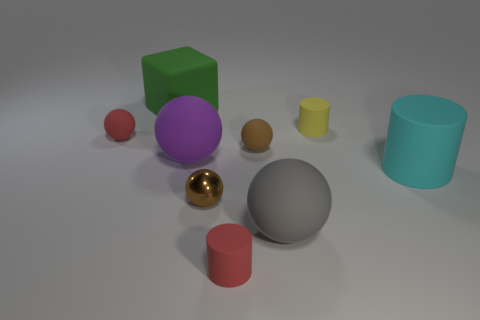There is a ball that is in front of the brown thing on the left side of the small matte sphere on the right side of the large cube; what size is it?
Your answer should be very brief. Large. There is a red rubber cylinder; does it have the same size as the gray matte sphere on the left side of the large cyan rubber thing?
Your answer should be very brief. No. Are there fewer green things to the left of the green rubber thing than cyan cylinders?
Your response must be concise. Yes. How many matte things are the same color as the shiny sphere?
Your answer should be compact. 1. Is the number of gray metal things less than the number of things?
Your response must be concise. Yes. Is the material of the big cyan object the same as the large purple object?
Keep it short and to the point. Yes. How many other things are the same size as the cyan rubber cylinder?
Your answer should be compact. 3. There is a large ball that is left of the tiny cylinder in front of the large cylinder; what is its color?
Give a very brief answer. Purple. How many other objects are the same shape as the green thing?
Your answer should be very brief. 0. Is there a tiny red cylinder made of the same material as the small yellow cylinder?
Your response must be concise. Yes. 